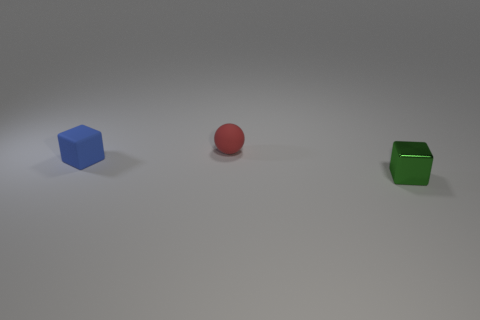Add 1 rubber things. How many objects exist? 4 Subtract all blocks. How many objects are left? 1 Subtract 0 green spheres. How many objects are left? 3 Subtract all blue matte cubes. Subtract all large yellow matte balls. How many objects are left? 2 Add 1 tiny blue blocks. How many tiny blue blocks are left? 2 Add 2 yellow shiny cylinders. How many yellow shiny cylinders exist? 2 